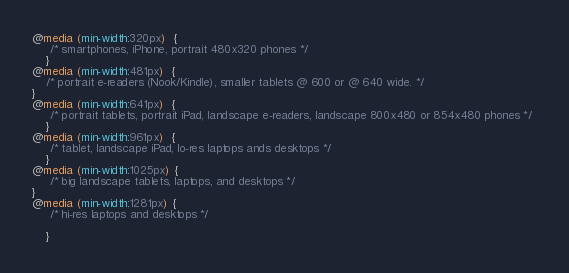Convert code to text. <code><loc_0><loc_0><loc_500><loc_500><_CSS_>
@media (min-width:320px)  {
     /* smartphones, iPhone, portrait 480x320 phones */ 
    }
@media (min-width:481px)  { 
    /* portrait e-readers (Nook/Kindle), smaller tablets @ 600 or @ 640 wide. */ 
}
@media (min-width:641px)  {
     /* portrait tablets, portrait iPad, landscape e-readers, landscape 800x480 or 854x480 phones */ 
    }
@media (min-width:961px)  {
     /* tablet, landscape iPad, lo-res laptops ands desktops */ 
    }
@media (min-width:1025px) {
     /* big landscape tablets, laptops, and desktops */ 
}
@media (min-width:1281px) {
     /* hi-res laptops and desktops */ 

    }</code> 